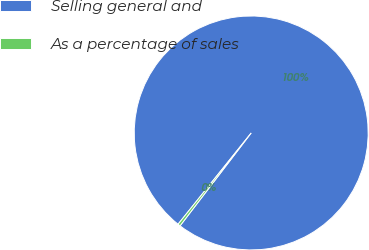Convert chart. <chart><loc_0><loc_0><loc_500><loc_500><pie_chart><fcel>Selling general and<fcel>As a percentage of sales<nl><fcel>99.65%<fcel>0.35%<nl></chart> 